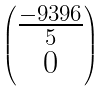Convert formula to latex. <formula><loc_0><loc_0><loc_500><loc_500>\begin{pmatrix} \frac { - 9 3 9 6 } { 5 } \\ 0 \end{pmatrix}</formula> 